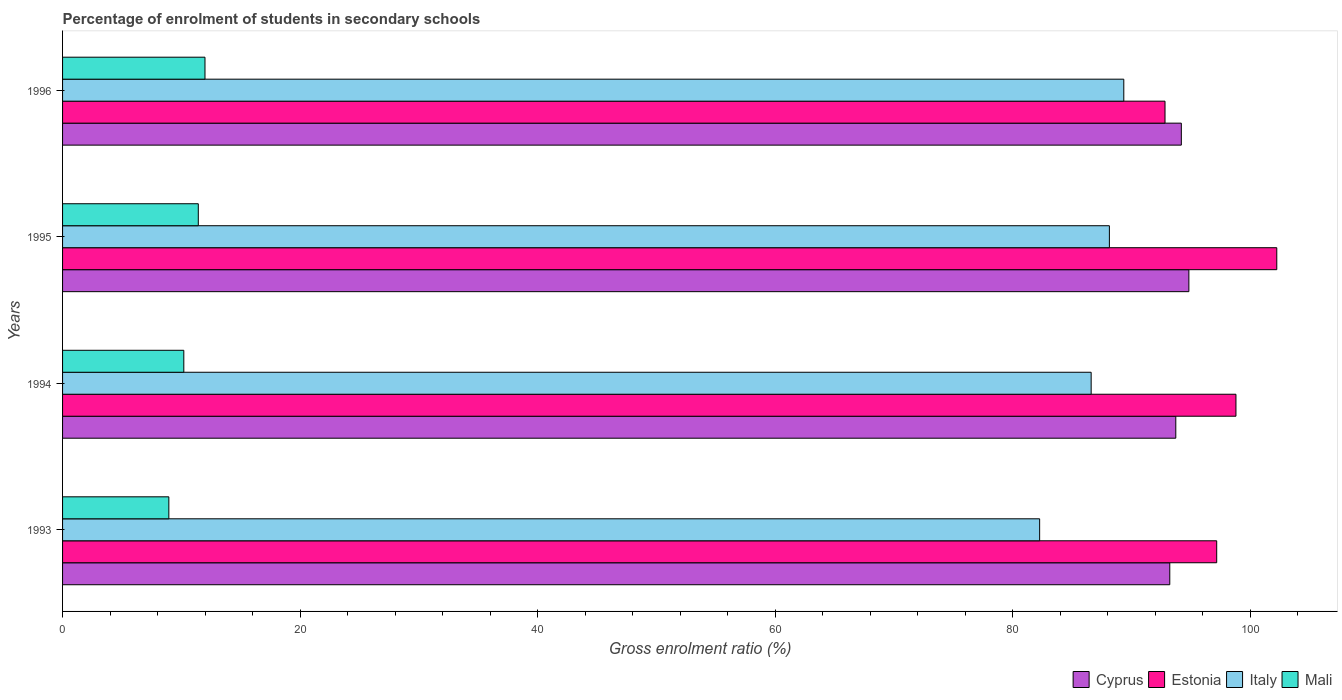How many groups of bars are there?
Provide a succinct answer. 4. Are the number of bars per tick equal to the number of legend labels?
Give a very brief answer. Yes. Are the number of bars on each tick of the Y-axis equal?
Offer a very short reply. Yes. How many bars are there on the 3rd tick from the top?
Give a very brief answer. 4. What is the label of the 4th group of bars from the top?
Ensure brevity in your answer.  1993. What is the percentage of students enrolled in secondary schools in Italy in 1996?
Keep it short and to the point. 89.37. Across all years, what is the maximum percentage of students enrolled in secondary schools in Estonia?
Your answer should be compact. 102.25. Across all years, what is the minimum percentage of students enrolled in secondary schools in Cyprus?
Ensure brevity in your answer.  93.24. In which year was the percentage of students enrolled in secondary schools in Cyprus maximum?
Your answer should be compact. 1995. What is the total percentage of students enrolled in secondary schools in Cyprus in the graph?
Offer a terse response. 376.04. What is the difference between the percentage of students enrolled in secondary schools in Estonia in 1993 and that in 1996?
Offer a very short reply. 4.35. What is the difference between the percentage of students enrolled in secondary schools in Estonia in 1993 and the percentage of students enrolled in secondary schools in Cyprus in 1994?
Your response must be concise. 3.45. What is the average percentage of students enrolled in secondary schools in Mali per year?
Your answer should be very brief. 10.65. In the year 1995, what is the difference between the percentage of students enrolled in secondary schools in Italy and percentage of students enrolled in secondary schools in Estonia?
Give a very brief answer. -14.1. What is the ratio of the percentage of students enrolled in secondary schools in Estonia in 1993 to that in 1994?
Ensure brevity in your answer.  0.98. Is the difference between the percentage of students enrolled in secondary schools in Italy in 1993 and 1996 greater than the difference between the percentage of students enrolled in secondary schools in Estonia in 1993 and 1996?
Your answer should be compact. No. What is the difference between the highest and the second highest percentage of students enrolled in secondary schools in Cyprus?
Your answer should be very brief. 0.63. What is the difference between the highest and the lowest percentage of students enrolled in secondary schools in Estonia?
Your answer should be compact. 9.41. In how many years, is the percentage of students enrolled in secondary schools in Estonia greater than the average percentage of students enrolled in secondary schools in Estonia taken over all years?
Give a very brief answer. 2. Is the sum of the percentage of students enrolled in secondary schools in Estonia in 1993 and 1996 greater than the maximum percentage of students enrolled in secondary schools in Mali across all years?
Make the answer very short. Yes. What does the 1st bar from the bottom in 1994 represents?
Your answer should be compact. Cyprus. How many bars are there?
Provide a short and direct response. 16. Are all the bars in the graph horizontal?
Your answer should be compact. Yes. How many years are there in the graph?
Give a very brief answer. 4. What is the difference between two consecutive major ticks on the X-axis?
Give a very brief answer. 20. Does the graph contain grids?
Offer a terse response. No. Where does the legend appear in the graph?
Keep it short and to the point. Bottom right. How are the legend labels stacked?
Your answer should be very brief. Horizontal. What is the title of the graph?
Provide a short and direct response. Percentage of enrolment of students in secondary schools. Does "Cabo Verde" appear as one of the legend labels in the graph?
Provide a succinct answer. No. What is the label or title of the Y-axis?
Provide a short and direct response. Years. What is the Gross enrolment ratio (%) of Cyprus in 1993?
Offer a very short reply. 93.24. What is the Gross enrolment ratio (%) in Estonia in 1993?
Your response must be concise. 97.19. What is the Gross enrolment ratio (%) in Italy in 1993?
Make the answer very short. 82.28. What is the Gross enrolment ratio (%) in Mali in 1993?
Ensure brevity in your answer.  8.95. What is the Gross enrolment ratio (%) in Cyprus in 1994?
Provide a succinct answer. 93.74. What is the Gross enrolment ratio (%) in Estonia in 1994?
Offer a very short reply. 98.81. What is the Gross enrolment ratio (%) of Italy in 1994?
Provide a succinct answer. 86.62. What is the Gross enrolment ratio (%) in Mali in 1994?
Offer a very short reply. 10.21. What is the Gross enrolment ratio (%) of Cyprus in 1995?
Make the answer very short. 94.85. What is the Gross enrolment ratio (%) in Estonia in 1995?
Give a very brief answer. 102.25. What is the Gross enrolment ratio (%) in Italy in 1995?
Give a very brief answer. 88.15. What is the Gross enrolment ratio (%) in Mali in 1995?
Your response must be concise. 11.43. What is the Gross enrolment ratio (%) of Cyprus in 1996?
Offer a terse response. 94.21. What is the Gross enrolment ratio (%) in Estonia in 1996?
Keep it short and to the point. 92.84. What is the Gross enrolment ratio (%) of Italy in 1996?
Offer a very short reply. 89.37. What is the Gross enrolment ratio (%) of Mali in 1996?
Give a very brief answer. 11.99. Across all years, what is the maximum Gross enrolment ratio (%) of Cyprus?
Your answer should be very brief. 94.85. Across all years, what is the maximum Gross enrolment ratio (%) of Estonia?
Provide a succinct answer. 102.25. Across all years, what is the maximum Gross enrolment ratio (%) of Italy?
Provide a short and direct response. 89.37. Across all years, what is the maximum Gross enrolment ratio (%) of Mali?
Make the answer very short. 11.99. Across all years, what is the minimum Gross enrolment ratio (%) of Cyprus?
Provide a succinct answer. 93.24. Across all years, what is the minimum Gross enrolment ratio (%) of Estonia?
Give a very brief answer. 92.84. Across all years, what is the minimum Gross enrolment ratio (%) in Italy?
Offer a very short reply. 82.28. Across all years, what is the minimum Gross enrolment ratio (%) of Mali?
Offer a terse response. 8.95. What is the total Gross enrolment ratio (%) of Cyprus in the graph?
Offer a terse response. 376.04. What is the total Gross enrolment ratio (%) in Estonia in the graph?
Ensure brevity in your answer.  391.09. What is the total Gross enrolment ratio (%) in Italy in the graph?
Give a very brief answer. 346.42. What is the total Gross enrolment ratio (%) of Mali in the graph?
Keep it short and to the point. 42.58. What is the difference between the Gross enrolment ratio (%) of Cyprus in 1993 and that in 1994?
Your answer should be very brief. -0.51. What is the difference between the Gross enrolment ratio (%) in Estonia in 1993 and that in 1994?
Your response must be concise. -1.62. What is the difference between the Gross enrolment ratio (%) of Italy in 1993 and that in 1994?
Offer a terse response. -4.34. What is the difference between the Gross enrolment ratio (%) in Mali in 1993 and that in 1994?
Your answer should be very brief. -1.26. What is the difference between the Gross enrolment ratio (%) in Cyprus in 1993 and that in 1995?
Provide a succinct answer. -1.61. What is the difference between the Gross enrolment ratio (%) in Estonia in 1993 and that in 1995?
Offer a terse response. -5.06. What is the difference between the Gross enrolment ratio (%) of Italy in 1993 and that in 1995?
Make the answer very short. -5.87. What is the difference between the Gross enrolment ratio (%) of Mali in 1993 and that in 1995?
Your answer should be compact. -2.48. What is the difference between the Gross enrolment ratio (%) of Cyprus in 1993 and that in 1996?
Offer a very short reply. -0.97. What is the difference between the Gross enrolment ratio (%) of Estonia in 1993 and that in 1996?
Keep it short and to the point. 4.35. What is the difference between the Gross enrolment ratio (%) in Italy in 1993 and that in 1996?
Your response must be concise. -7.09. What is the difference between the Gross enrolment ratio (%) of Mali in 1993 and that in 1996?
Your answer should be compact. -3.04. What is the difference between the Gross enrolment ratio (%) of Cyprus in 1994 and that in 1995?
Keep it short and to the point. -1.1. What is the difference between the Gross enrolment ratio (%) in Estonia in 1994 and that in 1995?
Offer a very short reply. -3.44. What is the difference between the Gross enrolment ratio (%) in Italy in 1994 and that in 1995?
Your response must be concise. -1.54. What is the difference between the Gross enrolment ratio (%) of Mali in 1994 and that in 1995?
Your response must be concise. -1.22. What is the difference between the Gross enrolment ratio (%) in Cyprus in 1994 and that in 1996?
Keep it short and to the point. -0.47. What is the difference between the Gross enrolment ratio (%) of Estonia in 1994 and that in 1996?
Your answer should be very brief. 5.97. What is the difference between the Gross enrolment ratio (%) in Italy in 1994 and that in 1996?
Ensure brevity in your answer.  -2.75. What is the difference between the Gross enrolment ratio (%) of Mali in 1994 and that in 1996?
Keep it short and to the point. -1.78. What is the difference between the Gross enrolment ratio (%) in Cyprus in 1995 and that in 1996?
Your answer should be compact. 0.63. What is the difference between the Gross enrolment ratio (%) of Estonia in 1995 and that in 1996?
Your answer should be very brief. 9.41. What is the difference between the Gross enrolment ratio (%) in Italy in 1995 and that in 1996?
Make the answer very short. -1.21. What is the difference between the Gross enrolment ratio (%) of Mali in 1995 and that in 1996?
Provide a succinct answer. -0.56. What is the difference between the Gross enrolment ratio (%) of Cyprus in 1993 and the Gross enrolment ratio (%) of Estonia in 1994?
Your answer should be very brief. -5.57. What is the difference between the Gross enrolment ratio (%) of Cyprus in 1993 and the Gross enrolment ratio (%) of Italy in 1994?
Offer a very short reply. 6.62. What is the difference between the Gross enrolment ratio (%) in Cyprus in 1993 and the Gross enrolment ratio (%) in Mali in 1994?
Provide a short and direct response. 83.03. What is the difference between the Gross enrolment ratio (%) of Estonia in 1993 and the Gross enrolment ratio (%) of Italy in 1994?
Offer a very short reply. 10.57. What is the difference between the Gross enrolment ratio (%) in Estonia in 1993 and the Gross enrolment ratio (%) in Mali in 1994?
Ensure brevity in your answer.  86.98. What is the difference between the Gross enrolment ratio (%) in Italy in 1993 and the Gross enrolment ratio (%) in Mali in 1994?
Your answer should be very brief. 72.07. What is the difference between the Gross enrolment ratio (%) in Cyprus in 1993 and the Gross enrolment ratio (%) in Estonia in 1995?
Give a very brief answer. -9.01. What is the difference between the Gross enrolment ratio (%) in Cyprus in 1993 and the Gross enrolment ratio (%) in Italy in 1995?
Your response must be concise. 5.09. What is the difference between the Gross enrolment ratio (%) in Cyprus in 1993 and the Gross enrolment ratio (%) in Mali in 1995?
Make the answer very short. 81.81. What is the difference between the Gross enrolment ratio (%) in Estonia in 1993 and the Gross enrolment ratio (%) in Italy in 1995?
Your answer should be very brief. 9.04. What is the difference between the Gross enrolment ratio (%) in Estonia in 1993 and the Gross enrolment ratio (%) in Mali in 1995?
Your answer should be very brief. 85.76. What is the difference between the Gross enrolment ratio (%) of Italy in 1993 and the Gross enrolment ratio (%) of Mali in 1995?
Your answer should be compact. 70.85. What is the difference between the Gross enrolment ratio (%) in Cyprus in 1993 and the Gross enrolment ratio (%) in Estonia in 1996?
Make the answer very short. 0.4. What is the difference between the Gross enrolment ratio (%) in Cyprus in 1993 and the Gross enrolment ratio (%) in Italy in 1996?
Make the answer very short. 3.87. What is the difference between the Gross enrolment ratio (%) of Cyprus in 1993 and the Gross enrolment ratio (%) of Mali in 1996?
Provide a short and direct response. 81.24. What is the difference between the Gross enrolment ratio (%) in Estonia in 1993 and the Gross enrolment ratio (%) in Italy in 1996?
Offer a terse response. 7.82. What is the difference between the Gross enrolment ratio (%) in Estonia in 1993 and the Gross enrolment ratio (%) in Mali in 1996?
Provide a succinct answer. 85.2. What is the difference between the Gross enrolment ratio (%) of Italy in 1993 and the Gross enrolment ratio (%) of Mali in 1996?
Offer a terse response. 70.29. What is the difference between the Gross enrolment ratio (%) of Cyprus in 1994 and the Gross enrolment ratio (%) of Estonia in 1995?
Your answer should be very brief. -8.5. What is the difference between the Gross enrolment ratio (%) in Cyprus in 1994 and the Gross enrolment ratio (%) in Italy in 1995?
Provide a short and direct response. 5.59. What is the difference between the Gross enrolment ratio (%) in Cyprus in 1994 and the Gross enrolment ratio (%) in Mali in 1995?
Provide a short and direct response. 82.31. What is the difference between the Gross enrolment ratio (%) of Estonia in 1994 and the Gross enrolment ratio (%) of Italy in 1995?
Keep it short and to the point. 10.66. What is the difference between the Gross enrolment ratio (%) in Estonia in 1994 and the Gross enrolment ratio (%) in Mali in 1995?
Ensure brevity in your answer.  87.38. What is the difference between the Gross enrolment ratio (%) in Italy in 1994 and the Gross enrolment ratio (%) in Mali in 1995?
Make the answer very short. 75.19. What is the difference between the Gross enrolment ratio (%) of Cyprus in 1994 and the Gross enrolment ratio (%) of Estonia in 1996?
Your answer should be very brief. 0.91. What is the difference between the Gross enrolment ratio (%) of Cyprus in 1994 and the Gross enrolment ratio (%) of Italy in 1996?
Ensure brevity in your answer.  4.38. What is the difference between the Gross enrolment ratio (%) of Cyprus in 1994 and the Gross enrolment ratio (%) of Mali in 1996?
Offer a very short reply. 81.75. What is the difference between the Gross enrolment ratio (%) of Estonia in 1994 and the Gross enrolment ratio (%) of Italy in 1996?
Your answer should be compact. 9.44. What is the difference between the Gross enrolment ratio (%) of Estonia in 1994 and the Gross enrolment ratio (%) of Mali in 1996?
Give a very brief answer. 86.82. What is the difference between the Gross enrolment ratio (%) in Italy in 1994 and the Gross enrolment ratio (%) in Mali in 1996?
Make the answer very short. 74.62. What is the difference between the Gross enrolment ratio (%) in Cyprus in 1995 and the Gross enrolment ratio (%) in Estonia in 1996?
Give a very brief answer. 2.01. What is the difference between the Gross enrolment ratio (%) in Cyprus in 1995 and the Gross enrolment ratio (%) in Italy in 1996?
Your answer should be compact. 5.48. What is the difference between the Gross enrolment ratio (%) in Cyprus in 1995 and the Gross enrolment ratio (%) in Mali in 1996?
Your response must be concise. 82.85. What is the difference between the Gross enrolment ratio (%) of Estonia in 1995 and the Gross enrolment ratio (%) of Italy in 1996?
Offer a terse response. 12.88. What is the difference between the Gross enrolment ratio (%) in Estonia in 1995 and the Gross enrolment ratio (%) in Mali in 1996?
Your response must be concise. 90.26. What is the difference between the Gross enrolment ratio (%) in Italy in 1995 and the Gross enrolment ratio (%) in Mali in 1996?
Your answer should be compact. 76.16. What is the average Gross enrolment ratio (%) of Cyprus per year?
Make the answer very short. 94.01. What is the average Gross enrolment ratio (%) of Estonia per year?
Ensure brevity in your answer.  97.77. What is the average Gross enrolment ratio (%) of Italy per year?
Keep it short and to the point. 86.6. What is the average Gross enrolment ratio (%) in Mali per year?
Provide a succinct answer. 10.65. In the year 1993, what is the difference between the Gross enrolment ratio (%) of Cyprus and Gross enrolment ratio (%) of Estonia?
Provide a succinct answer. -3.95. In the year 1993, what is the difference between the Gross enrolment ratio (%) in Cyprus and Gross enrolment ratio (%) in Italy?
Provide a succinct answer. 10.96. In the year 1993, what is the difference between the Gross enrolment ratio (%) in Cyprus and Gross enrolment ratio (%) in Mali?
Your response must be concise. 84.29. In the year 1993, what is the difference between the Gross enrolment ratio (%) of Estonia and Gross enrolment ratio (%) of Italy?
Keep it short and to the point. 14.91. In the year 1993, what is the difference between the Gross enrolment ratio (%) in Estonia and Gross enrolment ratio (%) in Mali?
Your answer should be very brief. 88.24. In the year 1993, what is the difference between the Gross enrolment ratio (%) of Italy and Gross enrolment ratio (%) of Mali?
Your response must be concise. 73.33. In the year 1994, what is the difference between the Gross enrolment ratio (%) in Cyprus and Gross enrolment ratio (%) in Estonia?
Ensure brevity in your answer.  -5.07. In the year 1994, what is the difference between the Gross enrolment ratio (%) in Cyprus and Gross enrolment ratio (%) in Italy?
Offer a terse response. 7.13. In the year 1994, what is the difference between the Gross enrolment ratio (%) of Cyprus and Gross enrolment ratio (%) of Mali?
Keep it short and to the point. 83.53. In the year 1994, what is the difference between the Gross enrolment ratio (%) of Estonia and Gross enrolment ratio (%) of Italy?
Give a very brief answer. 12.19. In the year 1994, what is the difference between the Gross enrolment ratio (%) in Estonia and Gross enrolment ratio (%) in Mali?
Keep it short and to the point. 88.6. In the year 1994, what is the difference between the Gross enrolment ratio (%) in Italy and Gross enrolment ratio (%) in Mali?
Give a very brief answer. 76.41. In the year 1995, what is the difference between the Gross enrolment ratio (%) in Cyprus and Gross enrolment ratio (%) in Estonia?
Provide a succinct answer. -7.4. In the year 1995, what is the difference between the Gross enrolment ratio (%) in Cyprus and Gross enrolment ratio (%) in Italy?
Offer a very short reply. 6.69. In the year 1995, what is the difference between the Gross enrolment ratio (%) in Cyprus and Gross enrolment ratio (%) in Mali?
Offer a very short reply. 83.42. In the year 1995, what is the difference between the Gross enrolment ratio (%) of Estonia and Gross enrolment ratio (%) of Italy?
Make the answer very short. 14.1. In the year 1995, what is the difference between the Gross enrolment ratio (%) of Estonia and Gross enrolment ratio (%) of Mali?
Give a very brief answer. 90.82. In the year 1995, what is the difference between the Gross enrolment ratio (%) in Italy and Gross enrolment ratio (%) in Mali?
Your response must be concise. 76.72. In the year 1996, what is the difference between the Gross enrolment ratio (%) in Cyprus and Gross enrolment ratio (%) in Estonia?
Your answer should be very brief. 1.37. In the year 1996, what is the difference between the Gross enrolment ratio (%) of Cyprus and Gross enrolment ratio (%) of Italy?
Give a very brief answer. 4.84. In the year 1996, what is the difference between the Gross enrolment ratio (%) of Cyprus and Gross enrolment ratio (%) of Mali?
Your response must be concise. 82.22. In the year 1996, what is the difference between the Gross enrolment ratio (%) of Estonia and Gross enrolment ratio (%) of Italy?
Your answer should be very brief. 3.47. In the year 1996, what is the difference between the Gross enrolment ratio (%) of Estonia and Gross enrolment ratio (%) of Mali?
Give a very brief answer. 80.84. In the year 1996, what is the difference between the Gross enrolment ratio (%) in Italy and Gross enrolment ratio (%) in Mali?
Offer a terse response. 77.37. What is the ratio of the Gross enrolment ratio (%) of Estonia in 1993 to that in 1994?
Provide a succinct answer. 0.98. What is the ratio of the Gross enrolment ratio (%) in Italy in 1993 to that in 1994?
Your answer should be compact. 0.95. What is the ratio of the Gross enrolment ratio (%) of Mali in 1993 to that in 1994?
Your answer should be compact. 0.88. What is the ratio of the Gross enrolment ratio (%) of Estonia in 1993 to that in 1995?
Provide a short and direct response. 0.95. What is the ratio of the Gross enrolment ratio (%) in Italy in 1993 to that in 1995?
Your answer should be compact. 0.93. What is the ratio of the Gross enrolment ratio (%) of Mali in 1993 to that in 1995?
Offer a terse response. 0.78. What is the ratio of the Gross enrolment ratio (%) of Cyprus in 1993 to that in 1996?
Offer a very short reply. 0.99. What is the ratio of the Gross enrolment ratio (%) in Estonia in 1993 to that in 1996?
Offer a terse response. 1.05. What is the ratio of the Gross enrolment ratio (%) in Italy in 1993 to that in 1996?
Provide a succinct answer. 0.92. What is the ratio of the Gross enrolment ratio (%) in Mali in 1993 to that in 1996?
Your answer should be compact. 0.75. What is the ratio of the Gross enrolment ratio (%) in Cyprus in 1994 to that in 1995?
Keep it short and to the point. 0.99. What is the ratio of the Gross enrolment ratio (%) of Estonia in 1994 to that in 1995?
Give a very brief answer. 0.97. What is the ratio of the Gross enrolment ratio (%) of Italy in 1994 to that in 1995?
Offer a very short reply. 0.98. What is the ratio of the Gross enrolment ratio (%) in Mali in 1994 to that in 1995?
Provide a succinct answer. 0.89. What is the ratio of the Gross enrolment ratio (%) in Estonia in 1994 to that in 1996?
Your answer should be compact. 1.06. What is the ratio of the Gross enrolment ratio (%) of Italy in 1994 to that in 1996?
Make the answer very short. 0.97. What is the ratio of the Gross enrolment ratio (%) in Mali in 1994 to that in 1996?
Your answer should be very brief. 0.85. What is the ratio of the Gross enrolment ratio (%) in Estonia in 1995 to that in 1996?
Provide a short and direct response. 1.1. What is the ratio of the Gross enrolment ratio (%) in Italy in 1995 to that in 1996?
Provide a short and direct response. 0.99. What is the ratio of the Gross enrolment ratio (%) of Mali in 1995 to that in 1996?
Your response must be concise. 0.95. What is the difference between the highest and the second highest Gross enrolment ratio (%) in Cyprus?
Ensure brevity in your answer.  0.63. What is the difference between the highest and the second highest Gross enrolment ratio (%) of Estonia?
Offer a very short reply. 3.44. What is the difference between the highest and the second highest Gross enrolment ratio (%) in Italy?
Your response must be concise. 1.21. What is the difference between the highest and the second highest Gross enrolment ratio (%) of Mali?
Your answer should be very brief. 0.56. What is the difference between the highest and the lowest Gross enrolment ratio (%) of Cyprus?
Your response must be concise. 1.61. What is the difference between the highest and the lowest Gross enrolment ratio (%) of Estonia?
Offer a very short reply. 9.41. What is the difference between the highest and the lowest Gross enrolment ratio (%) in Italy?
Your answer should be compact. 7.09. What is the difference between the highest and the lowest Gross enrolment ratio (%) in Mali?
Your response must be concise. 3.04. 